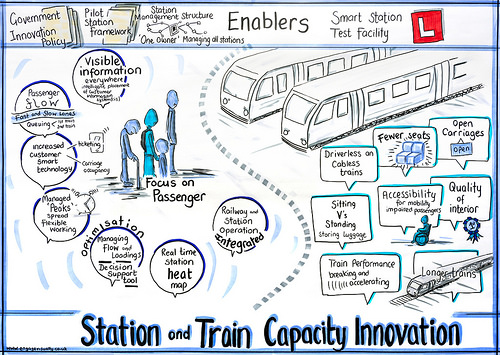<image>
Is there a train behind the seat? No. The train is not behind the seat. From this viewpoint, the train appears to be positioned elsewhere in the scene. 